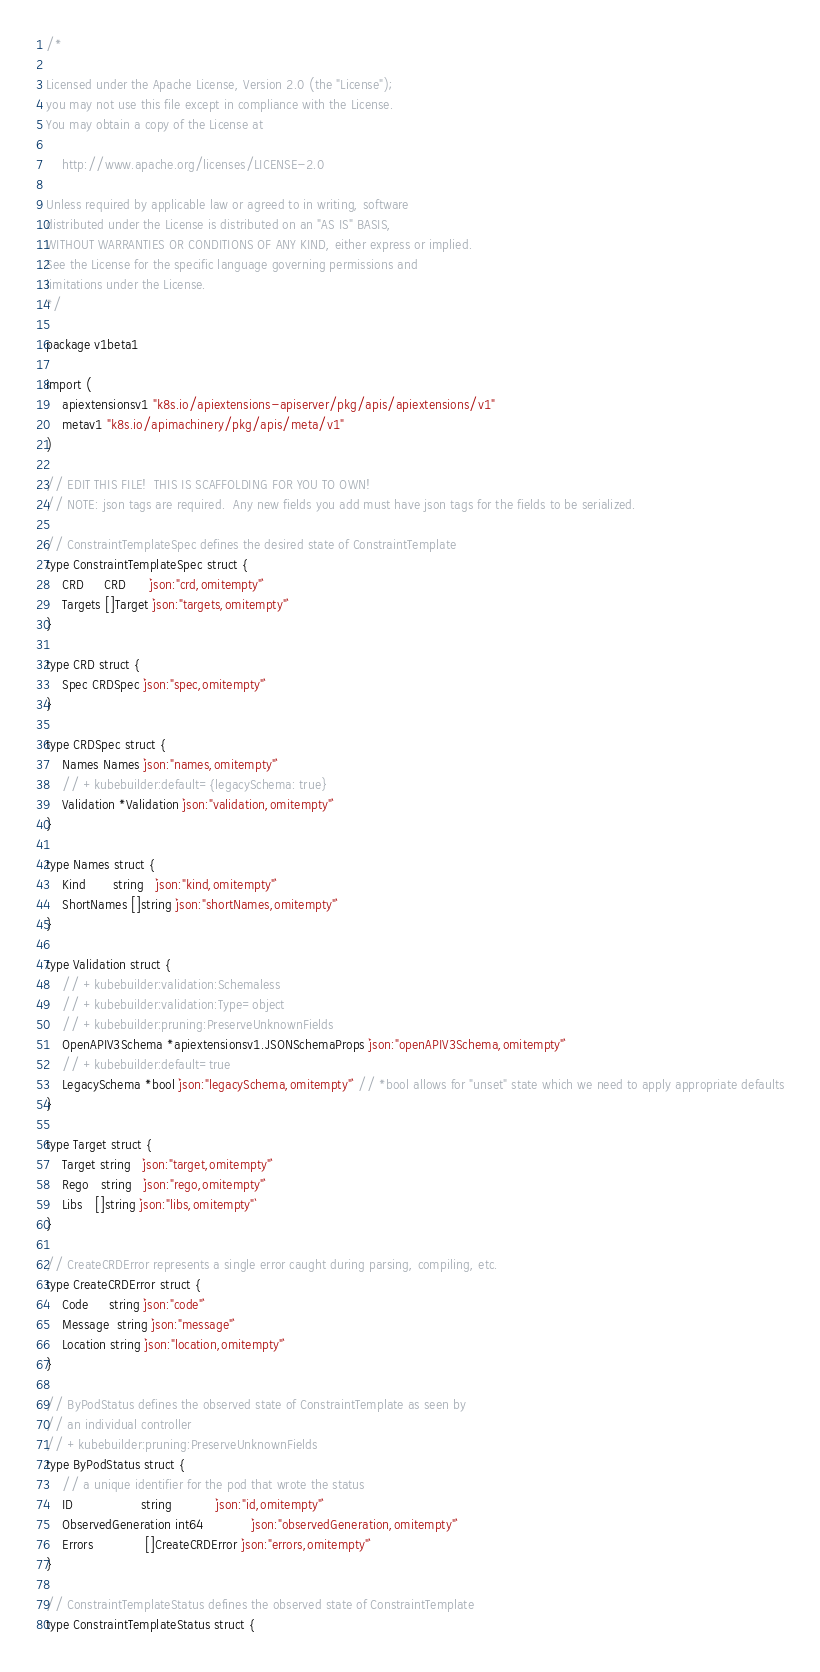<code> <loc_0><loc_0><loc_500><loc_500><_Go_>/*

Licensed under the Apache License, Version 2.0 (the "License");
you may not use this file except in compliance with the License.
You may obtain a copy of the License at

    http://www.apache.org/licenses/LICENSE-2.0

Unless required by applicable law or agreed to in writing, software
distributed under the License is distributed on an "AS IS" BASIS,
WITHOUT WARRANTIES OR CONDITIONS OF ANY KIND, either express or implied.
See the License for the specific language governing permissions and
limitations under the License.
*/

package v1beta1

import (
	apiextensionsv1 "k8s.io/apiextensions-apiserver/pkg/apis/apiextensions/v1"
	metav1 "k8s.io/apimachinery/pkg/apis/meta/v1"
)

// EDIT THIS FILE!  THIS IS SCAFFOLDING FOR YOU TO OWN!
// NOTE: json tags are required.  Any new fields you add must have json tags for the fields to be serialized.

// ConstraintTemplateSpec defines the desired state of ConstraintTemplate
type ConstraintTemplateSpec struct {
	CRD     CRD      `json:"crd,omitempty"`
	Targets []Target `json:"targets,omitempty"`
}

type CRD struct {
	Spec CRDSpec `json:"spec,omitempty"`
}

type CRDSpec struct {
	Names Names `json:"names,omitempty"`
	// +kubebuilder:default={legacySchema: true}
	Validation *Validation `json:"validation,omitempty"`
}

type Names struct {
	Kind       string   `json:"kind,omitempty"`
	ShortNames []string `json:"shortNames,omitempty"`
}

type Validation struct {
	// +kubebuilder:validation:Schemaless
	// +kubebuilder:validation:Type=object
	// +kubebuilder:pruning:PreserveUnknownFields
	OpenAPIV3Schema *apiextensionsv1.JSONSchemaProps `json:"openAPIV3Schema,omitempty"`
	// +kubebuilder:default=true
	LegacySchema *bool `json:"legacySchema,omitempty"` // *bool allows for "unset" state which we need to apply appropriate defaults
}

type Target struct {
	Target string   `json:"target,omitempty"`
	Rego   string   `json:"rego,omitempty"`
	Libs   []string `json:"libs,omitempty"`
}

// CreateCRDError represents a single error caught during parsing, compiling, etc.
type CreateCRDError struct {
	Code     string `json:"code"`
	Message  string `json:"message"`
	Location string `json:"location,omitempty"`
}

// ByPodStatus defines the observed state of ConstraintTemplate as seen by
// an individual controller
// +kubebuilder:pruning:PreserveUnknownFields
type ByPodStatus struct {
	// a unique identifier for the pod that wrote the status
	ID                 string           `json:"id,omitempty"`
	ObservedGeneration int64            `json:"observedGeneration,omitempty"`
	Errors             []CreateCRDError `json:"errors,omitempty"`
}

// ConstraintTemplateStatus defines the observed state of ConstraintTemplate
type ConstraintTemplateStatus struct {</code> 